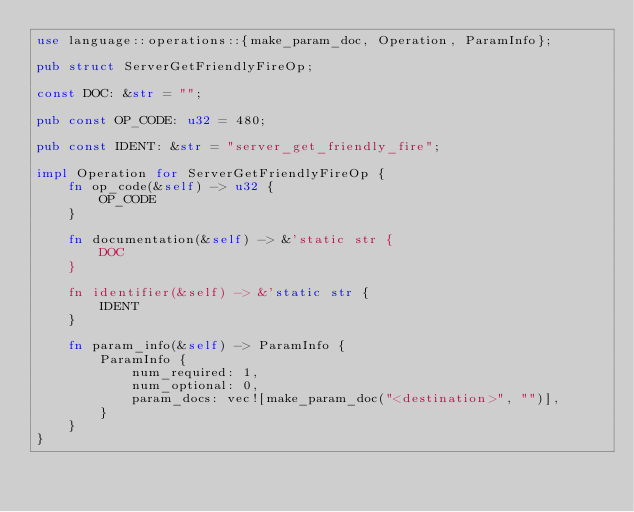Convert code to text. <code><loc_0><loc_0><loc_500><loc_500><_Rust_>use language::operations::{make_param_doc, Operation, ParamInfo};

pub struct ServerGetFriendlyFireOp;

const DOC: &str = "";

pub const OP_CODE: u32 = 480;

pub const IDENT: &str = "server_get_friendly_fire";

impl Operation for ServerGetFriendlyFireOp {
    fn op_code(&self) -> u32 {
        OP_CODE
    }

    fn documentation(&self) -> &'static str {
        DOC
    }

    fn identifier(&self) -> &'static str {
        IDENT
    }

    fn param_info(&self) -> ParamInfo {
        ParamInfo {
            num_required: 1,
            num_optional: 0,
            param_docs: vec![make_param_doc("<destination>", "")],
        }
    }
}
</code> 